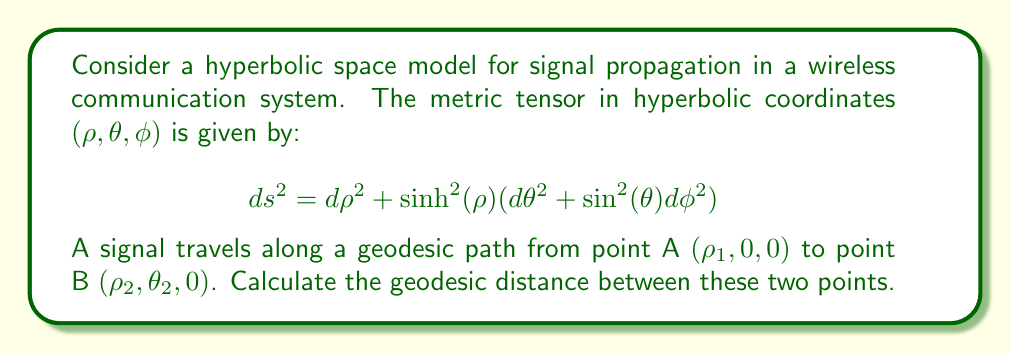Can you solve this math problem? To solve this problem, we'll follow these steps:

1) In hyperbolic space, the geodesic distance between two points is given by the hyperbolic law of cosines:

   $$ \cosh(d) = \cosh(ρ_1)\cosh(ρ_2) - \sinh(ρ_1)\sinh(ρ_2)\cos(θ_2) $$

   where $d$ is the geodesic distance.

2) We need to solve this equation for $d$. First, let's apply the inverse hyperbolic cosine (arccosh) to both sides:

   $$ d = \textrm{arccosh}(\cosh(ρ_1)\cosh(ρ_2) - \sinh(ρ_1)\sinh(ρ_2)\cos(θ_2)) $$

3) This is our final formula. To use it in a practical scenario, we would need specific values for $ρ_1$, $ρ_2$, and $θ_2$.

4) It's worth noting that this formula reduces to the Euclidean distance formula when $ρ_1$ and $ρ_2$ are small, as the hyperbolic space becomes approximately flat for small distances from the origin.

5) In the context of wireless communications, this geodesic distance could represent the path a signal would take in a non-Euclidean environment, which could be useful for more accurate signal strength predictions or improved localization algorithms.
Answer: $d = \textrm{arccosh}(\cosh(ρ_1)\cosh(ρ_2) - \sinh(ρ_1)\sinh(ρ_2)\cos(θ_2))$ 